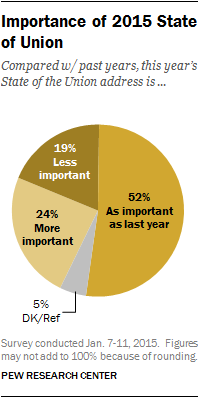List a handful of essential elements in this visual. I will add the two categories of 'More important' and 'As important as last year', and divide the total by the category of 'Less important'. The pie chart shows that 52% of the value is in one category, and it is important to find out which category that is and determine if it is as important as last year. 